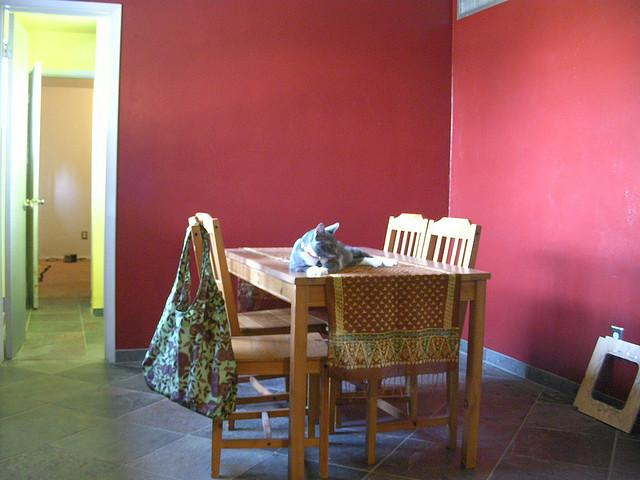What is the cat on top of? Please explain your reasoning. table. The cat is on top of dining furniture. 